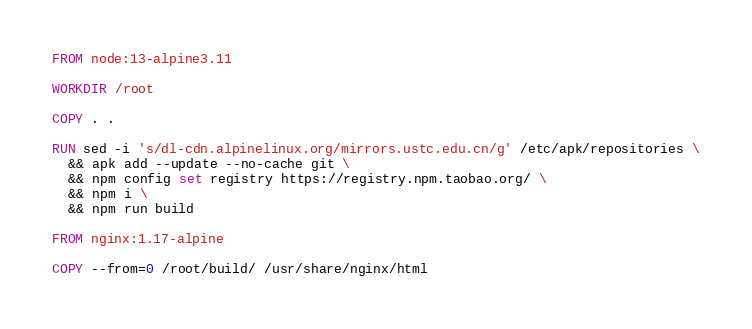<code> <loc_0><loc_0><loc_500><loc_500><_Dockerfile_>FROM node:13-alpine3.11

WORKDIR /root

COPY . .

RUN sed -i 's/dl-cdn.alpinelinux.org/mirrors.ustc.edu.cn/g' /etc/apk/repositories \
  && apk add --update --no-cache git \
  && npm config set registry https://registry.npm.taobao.org/ \
  && npm i \
  && npm run build

FROM nginx:1.17-alpine

COPY --from=0 /root/build/ /usr/share/nginx/html</code> 